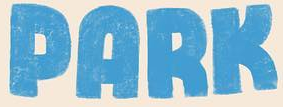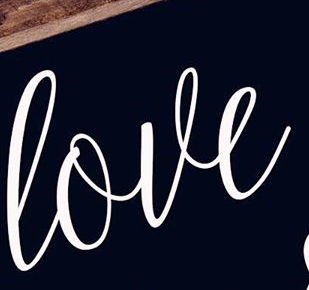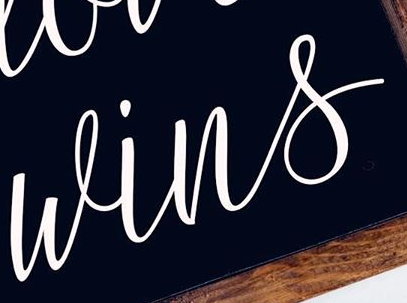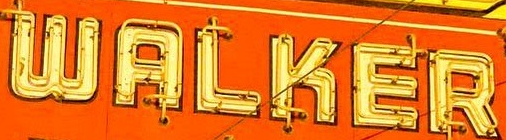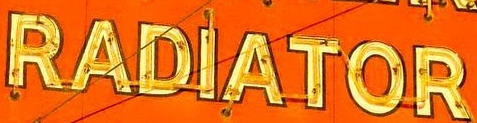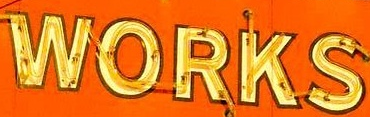What words are shown in these images in order, separated by a semicolon? PARK; love; wins; WALKER; RADIATOR; WORKS 